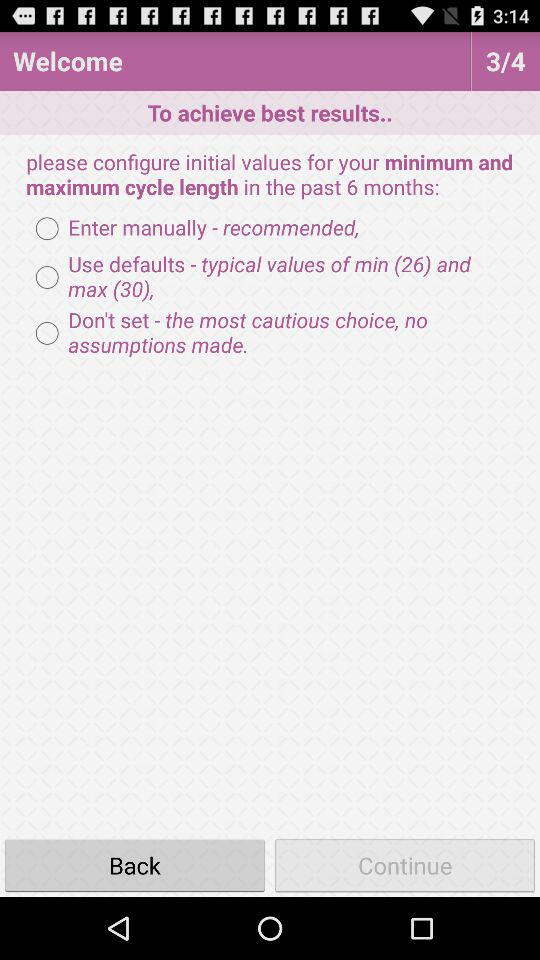Which radio button is selected?
When the provided information is insufficient, respond with <no answer>. <no answer> 